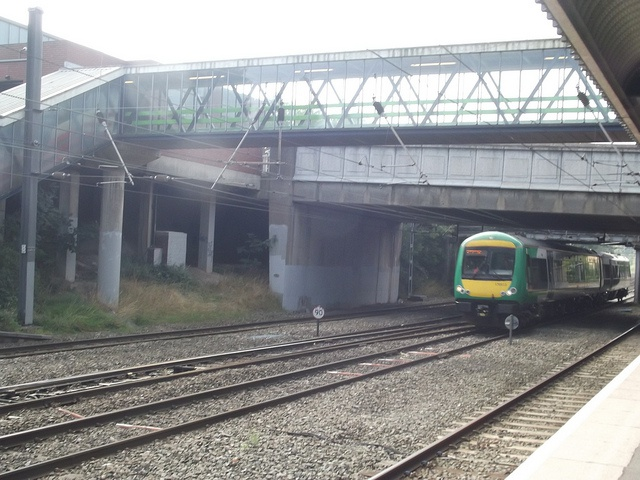Describe the objects in this image and their specific colors. I can see a train in white, gray, black, and teal tones in this image. 